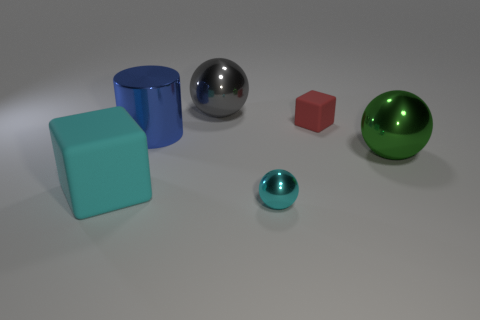What number of things are tiny objects in front of the small cube or small brown metal objects?
Keep it short and to the point. 1. What number of gray objects are tiny matte things or big matte cubes?
Keep it short and to the point. 0. What number of other things are there of the same color as the small matte object?
Your response must be concise. 0. Are there fewer small red matte blocks that are in front of the large matte thing than blue shiny objects?
Keep it short and to the point. Yes. There is a cube in front of the blue object to the right of the cyan block that is in front of the large blue thing; what color is it?
Your response must be concise. Cyan. Is there anything else that is made of the same material as the green ball?
Offer a very short reply. Yes. What size is the gray object that is the same shape as the cyan metal thing?
Ensure brevity in your answer.  Large. Is the number of gray spheres in front of the cyan metallic sphere less than the number of big blocks that are on the right side of the big gray thing?
Your answer should be compact. No. There is a big object that is both in front of the blue cylinder and on the right side of the cyan matte cube; what shape is it?
Provide a short and direct response. Sphere. The cylinder that is the same material as the gray ball is what size?
Offer a very short reply. Large. 